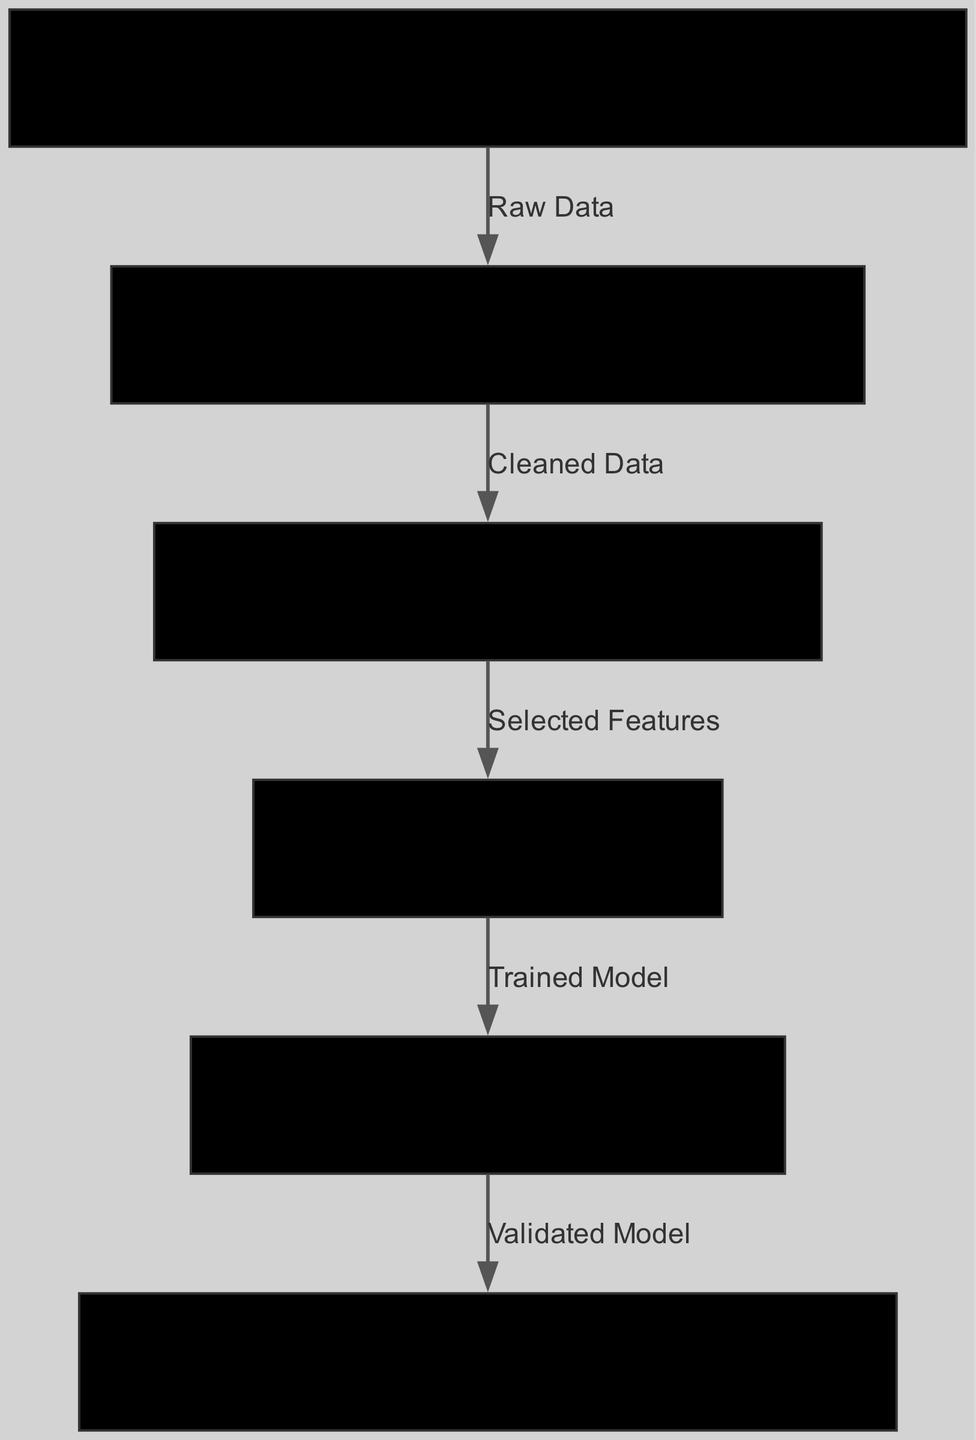What is the first stage in the machine learning pipeline? The diagram indicates that the first stage is "Customer Data Collection," which collects data from various sources.
Answer: Customer Data Collection How many nodes are present in the diagram? The diagram has six nodes representing different stages of the pipeline.
Answer: Six What type of data is moved from "Data Preprocessing" to "Feature Selection"? The edge indicates that "Cleaned Data" is the data being moved from "Data Preprocessing" to "Feature Selection."
Answer: Cleaned Data Which algorithm is used during the "Model Training" phase? The details of the "Model Training" node explicitly state that the Random Forest algorithm is used in this phase.
Answer: Random Forest What does the "Model Evaluation" stage utilize to assess the model? The "Model Evaluation" node mentions using cross-validation along with accuracy metrics to evaluate the model's performance.
Answer: Cross-validation, accuracy metrics What is the final output of the machine learning pipeline? The diagram shows that "Preference Prediction" is the final output stage that recommends products based on the customer profiles created from the pipeline.
Answer: Recommend products based on customer profiles Which process comes after "Feature Selection"? According to the edges in the diagram, the process that follows "Feature Selection" is "Model Training."
Answer: Model Training What does "Data Preprocessing" handle specifically? The details in the "Data Preprocessing" node specify that it involves cleaning data, handling missing values, and normalizing it.
Answer: Clean, handle missing values, normalize 